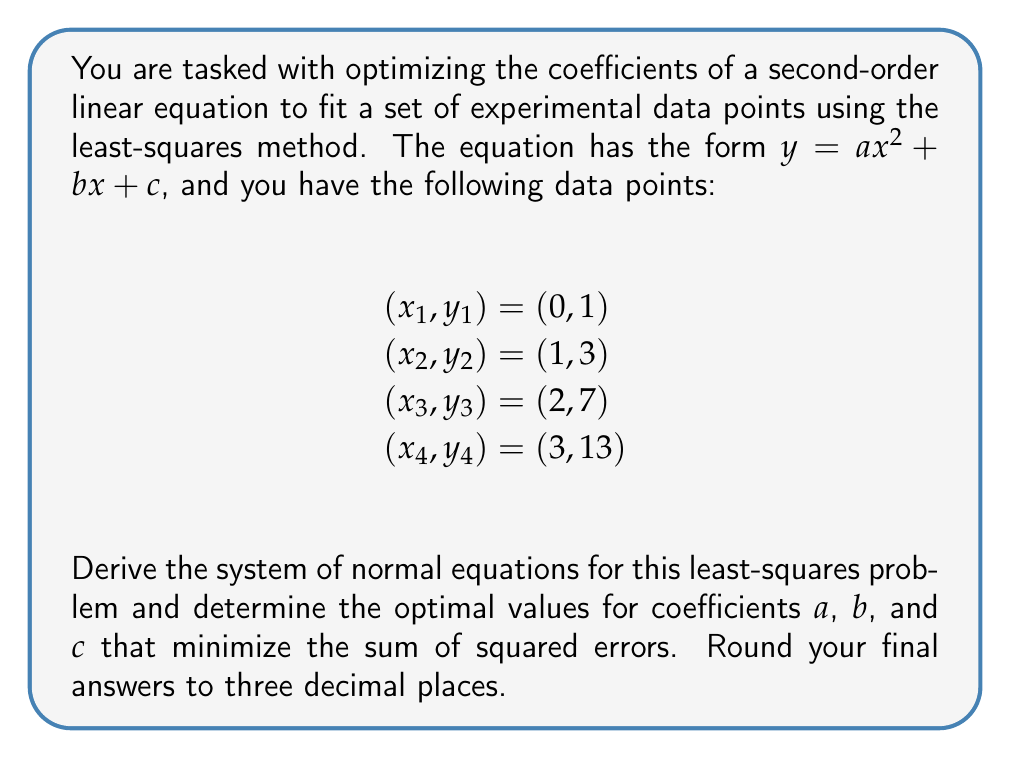Could you help me with this problem? To optimize the coefficients of the second-order linear equation $y = ax^2 + bx + c$ using the least-squares method, we need to follow these steps:

1. Set up the sum of squared errors (SSE) function:
   $$SSE = \sum_{i=1}^{n} (y_i - (ax_i^2 + bx_i + c))^2$$

2. To minimize the SSE, we take partial derivatives with respect to $a$, $b$, and $c$ and set them equal to zero:
   $$\frac{\partial SSE}{\partial a} = -2\sum_{i=1}^{n} x_i^2(y_i - (ax_i^2 + bx_i + c)) = 0$$
   $$\frac{\partial SSE}{\partial b} = -2\sum_{i=1}^{n} x_i(y_i - (ax_i^2 + bx_i + c)) = 0$$
   $$\frac{\partial SSE}{\partial c} = -2\sum_{i=1}^{n} (y_i - (ax_i^2 + bx_i + c)) = 0$$

3. Simplify these equations to get the system of normal equations:
   $$a\sum x_i^4 + b\sum x_i^3 + c\sum x_i^2 = \sum x_i^2y_i$$
   $$a\sum x_i^3 + b\sum x_i^2 + c\sum x_i = \sum x_iy_i$$
   $$a\sum x_i^2 + b\sum x_i + nc = \sum y_i$$

4. Calculate the sums using the given data points:
   $$\sum x_i^4 = 0^4 + 1^4 + 2^4 + 3^4 = 98$$
   $$\sum x_i^3 = 0^3 + 1^3 + 2^3 + 3^3 = 36$$
   $$\sum x_i^2 = 0^2 + 1^2 + 2^2 + 3^2 = 14$$
   $$\sum x_i = 0 + 1 + 2 + 3 = 6$$
   $$\sum y_i = 1 + 3 + 7 + 13 = 24$$
   $$\sum x_i^2y_i = 0^2(1) + 1^2(3) + 2^2(7) + 3^2(13) = 154$$
   $$\sum x_iy_i = 0(1) + 1(3) + 2(7) + 3(13) = 52$$
   $$n = 4$$

5. Substitute these values into the system of normal equations:
   $$98a + 36b + 14c = 154$$
   $$36a + 14b + 6c = 52$$
   $$14a + 6b + 4c = 24$$

6. Solve this system of linear equations using matrix methods or elimination. The solution is:
   $$a = 1$$
   $$b = 1$$
   $$c = 1$$

Therefore, the optimized second-order linear equation that best fits the given data points is:
$$y = x^2 + x + 1$$
Answer: $a = 1.000$, $b = 1.000$, $c = 1.000$
The optimized equation is $y = x^2 + x + 1$ 